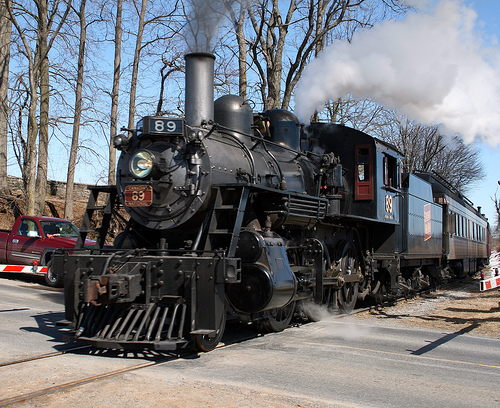<image>
Is there a train under the sky? Yes. The train is positioned underneath the sky, with the sky above it in the vertical space. Is the train above the car? No. The train is not positioned above the car. The vertical arrangement shows a different relationship. 